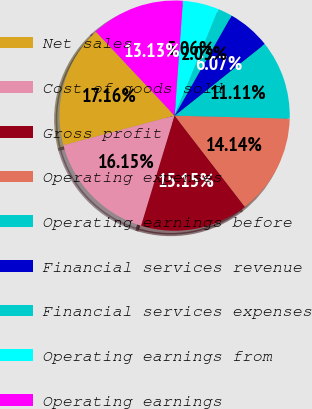Convert chart. <chart><loc_0><loc_0><loc_500><loc_500><pie_chart><fcel>Net sales<fcel>Cost of goods sold<fcel>Gross profit<fcel>Operating expenses<fcel>Operating earnings before<fcel>Financial services revenue<fcel>Financial services expenses<fcel>Operating earnings from<fcel>Operating earnings<nl><fcel>17.16%<fcel>16.15%<fcel>15.15%<fcel>14.14%<fcel>11.11%<fcel>6.07%<fcel>2.03%<fcel>5.06%<fcel>13.13%<nl></chart> 